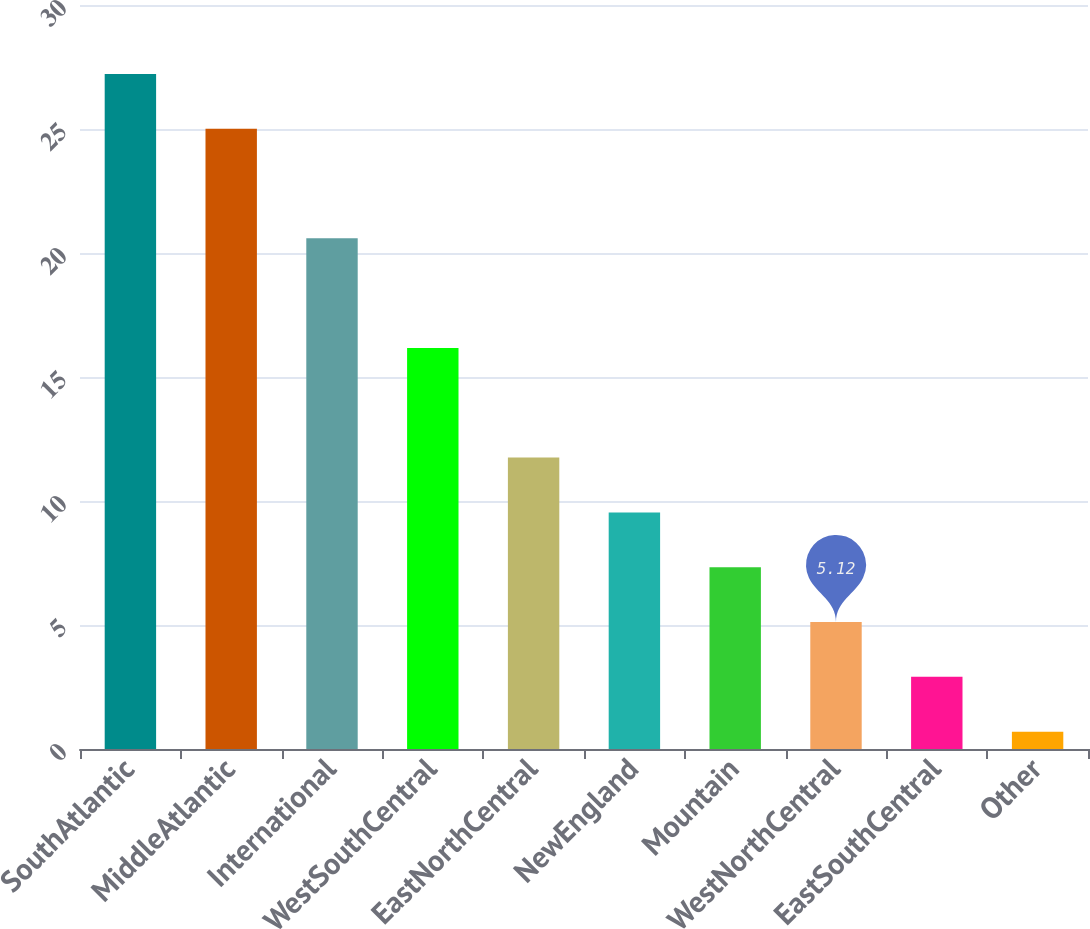Convert chart to OTSL. <chart><loc_0><loc_0><loc_500><loc_500><bar_chart><fcel>SouthAtlantic<fcel>MiddleAtlantic<fcel>International<fcel>WestSouthCentral<fcel>EastNorthCentral<fcel>NewEngland<fcel>Mountain<fcel>WestNorthCentral<fcel>EastSouthCentral<fcel>Other<nl><fcel>27.22<fcel>25.01<fcel>20.59<fcel>16.17<fcel>11.75<fcel>9.54<fcel>7.33<fcel>5.12<fcel>2.91<fcel>0.7<nl></chart> 